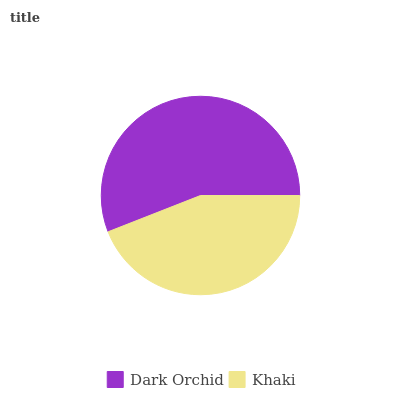Is Khaki the minimum?
Answer yes or no. Yes. Is Dark Orchid the maximum?
Answer yes or no. Yes. Is Khaki the maximum?
Answer yes or no. No. Is Dark Orchid greater than Khaki?
Answer yes or no. Yes. Is Khaki less than Dark Orchid?
Answer yes or no. Yes. Is Khaki greater than Dark Orchid?
Answer yes or no. No. Is Dark Orchid less than Khaki?
Answer yes or no. No. Is Dark Orchid the high median?
Answer yes or no. Yes. Is Khaki the low median?
Answer yes or no. Yes. Is Khaki the high median?
Answer yes or no. No. Is Dark Orchid the low median?
Answer yes or no. No. 